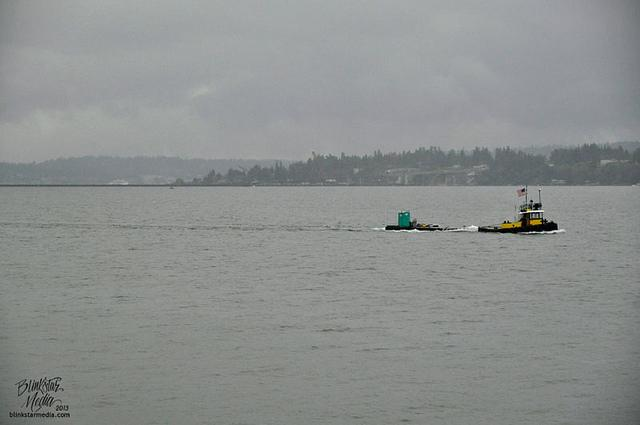The green object on the smaller boat is used as what? bathroom 